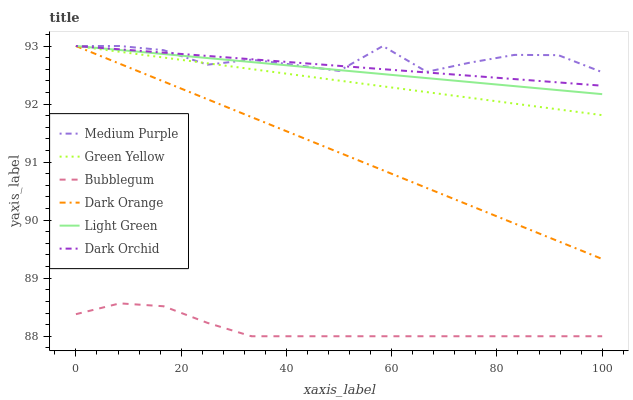Does Bubblegum have the minimum area under the curve?
Answer yes or no. Yes. Does Medium Purple have the maximum area under the curve?
Answer yes or no. Yes. Does Dark Orchid have the minimum area under the curve?
Answer yes or no. No. Does Dark Orchid have the maximum area under the curve?
Answer yes or no. No. Is Dark Orchid the smoothest?
Answer yes or no. Yes. Is Medium Purple the roughest?
Answer yes or no. Yes. Is Medium Purple the smoothest?
Answer yes or no. No. Is Dark Orchid the roughest?
Answer yes or no. No. Does Bubblegum have the lowest value?
Answer yes or no. Yes. Does Dark Orchid have the lowest value?
Answer yes or no. No. Does Green Yellow have the highest value?
Answer yes or no. Yes. Does Bubblegum have the highest value?
Answer yes or no. No. Is Bubblegum less than Green Yellow?
Answer yes or no. Yes. Is Green Yellow greater than Bubblegum?
Answer yes or no. Yes. Does Medium Purple intersect Dark Orange?
Answer yes or no. Yes. Is Medium Purple less than Dark Orange?
Answer yes or no. No. Is Medium Purple greater than Dark Orange?
Answer yes or no. No. Does Bubblegum intersect Green Yellow?
Answer yes or no. No. 